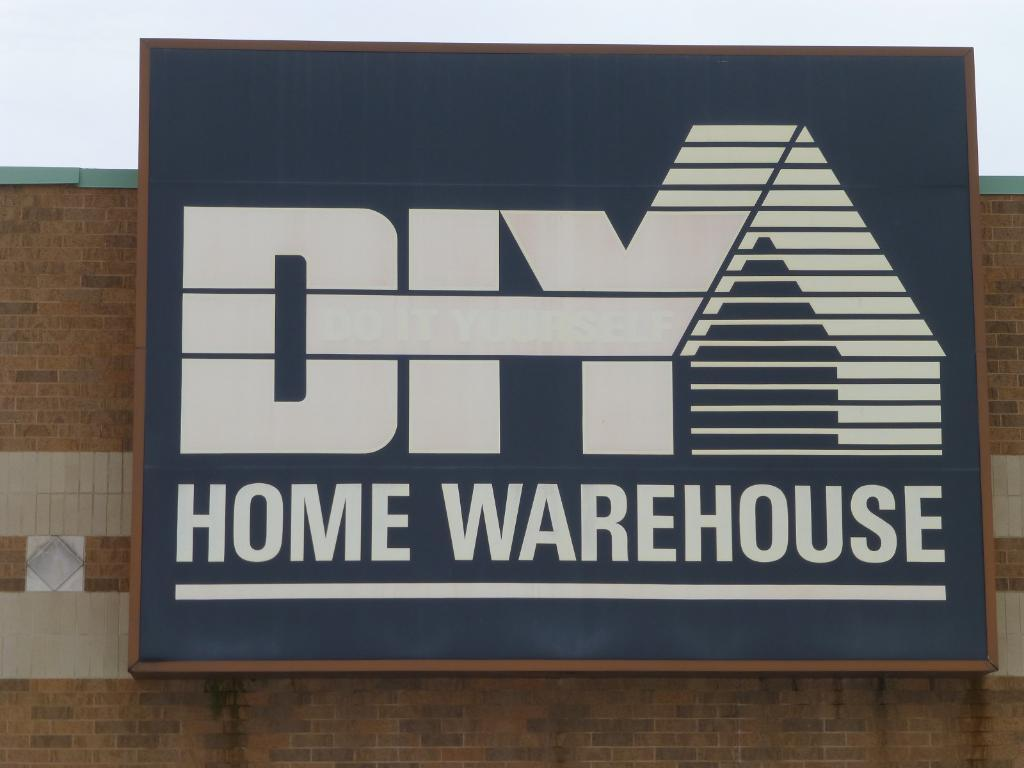What type of structure can be seen in the image? There is a wall in the image. What is attached to the wall in the image? There is a board with text in the image. What part of the natural environment is visible in the image? The sky is visible in the image. What type of cream can be seen on the gate in the image? There is no gate or cream present in the image; it only features a wall and a board with text. 